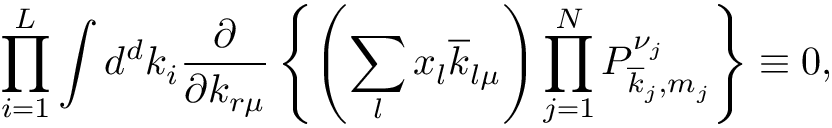<formula> <loc_0><loc_0><loc_500><loc_500>\prod _ { i = 1 } ^ { L } \int d ^ { d } k _ { i } \frac { \partial } { \partial k _ { r \mu } } \left \{ \left ( \sum _ { l } x _ { l } \overline { k } _ { l \mu } \right ) \prod _ { j = 1 } ^ { N } P _ { \overline { k } _ { j } , m _ { j } } ^ { \nu _ { j } } \right \} \equiv 0 ,</formula> 